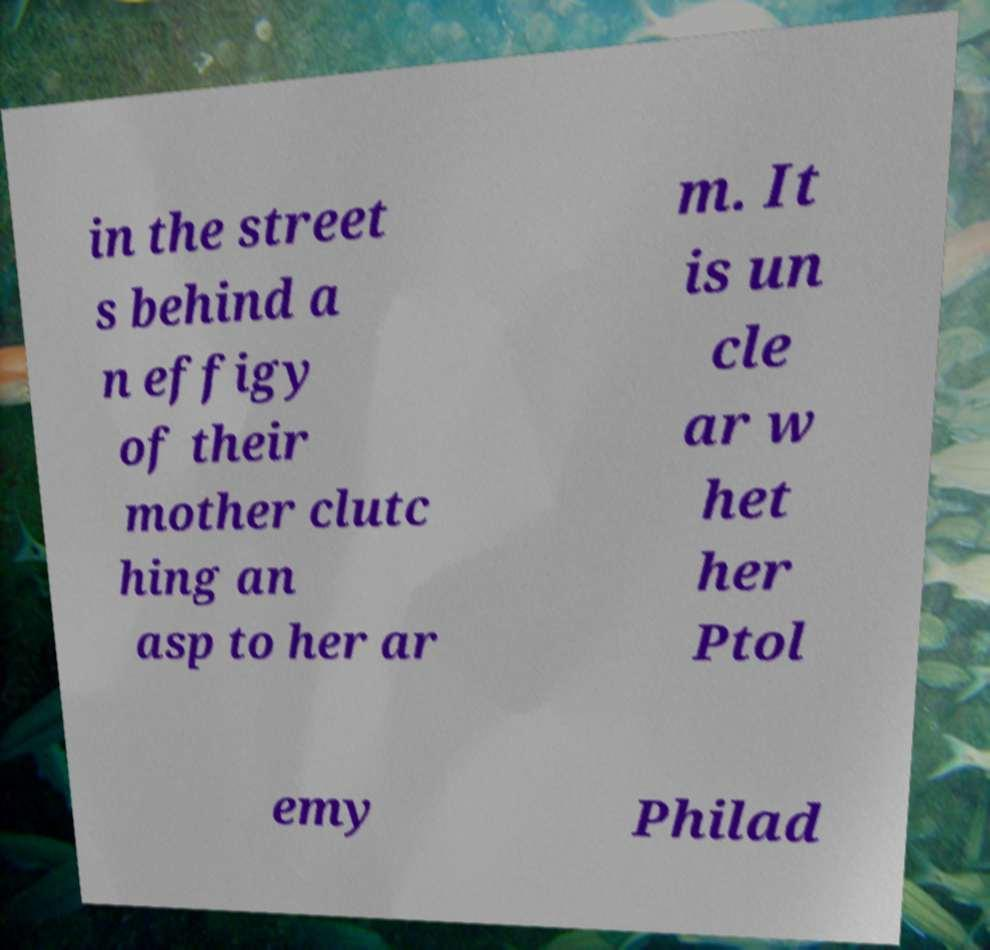There's text embedded in this image that I need extracted. Can you transcribe it verbatim? in the street s behind a n effigy of their mother clutc hing an asp to her ar m. It is un cle ar w het her Ptol emy Philad 